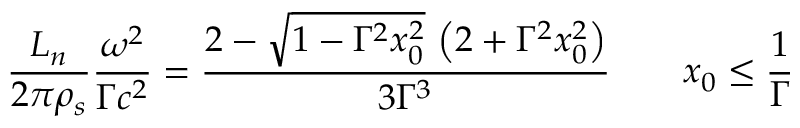Convert formula to latex. <formula><loc_0><loc_0><loc_500><loc_500>\frac { L _ { n } } { 2 \pi \rho _ { s } } \frac { \omega ^ { 2 } } { \Gamma c ^ { 2 } } = \frac { 2 - \sqrt { 1 - \Gamma ^ { 2 } x _ { 0 } ^ { 2 } } \, \left ( 2 + \Gamma ^ { 2 } x _ { 0 } ^ { 2 } \right ) } { 3 \Gamma ^ { 3 } } \quad x _ { 0 } \leq \frac { 1 } { \Gamma }</formula> 